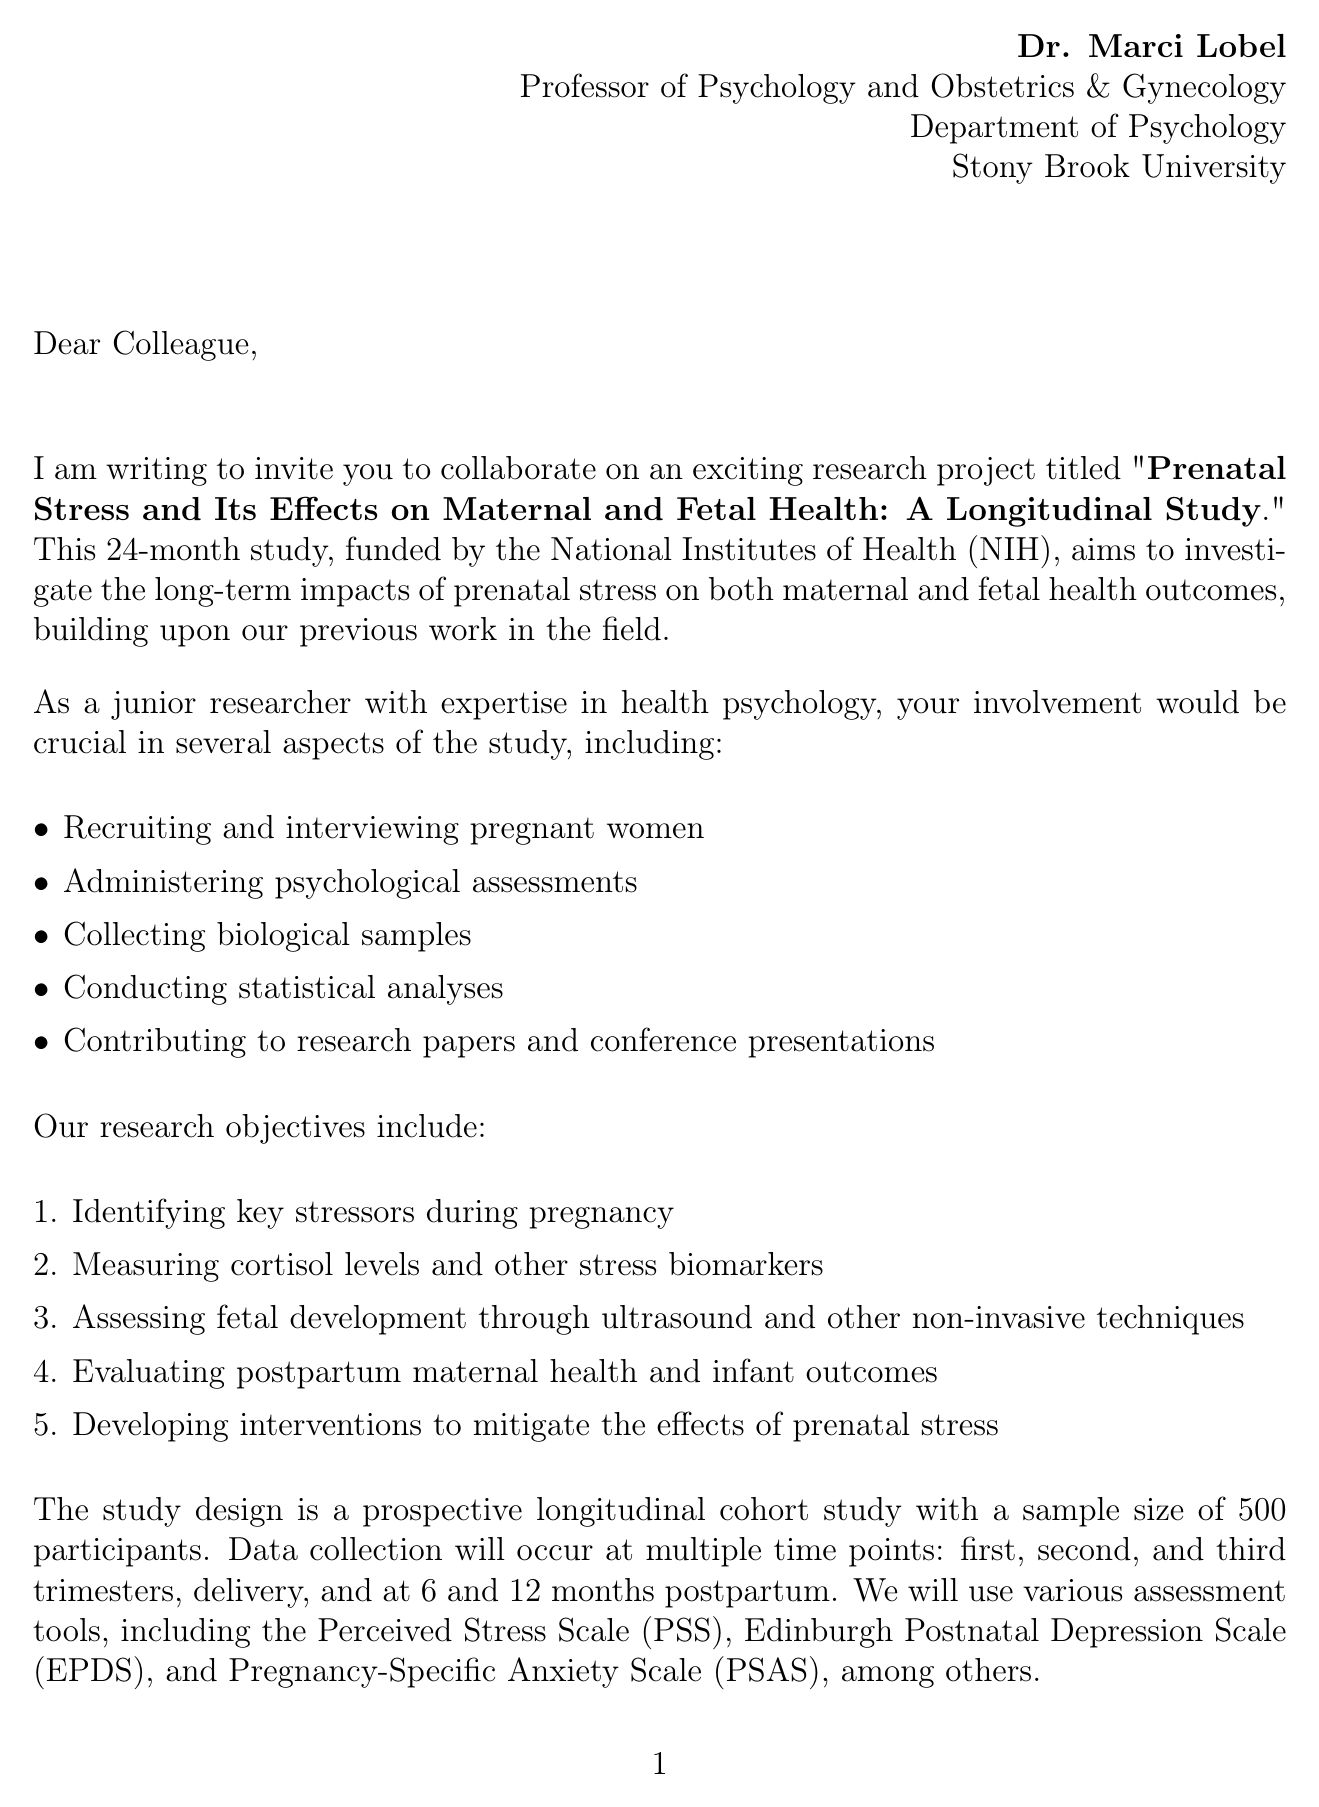What is the title of the research project? The title is stated in the beginning of the letter as "Prenatal Stress and Its Effects on Maternal and Fetal Health: A Longitudinal Study."
Answer: Prenatal Stress and Its Effects on Maternal and Fetal Health: A Longitudinal Study Who is the sender of the letter? The sender's details are provided at the top of the document, identifying the sender as Dr. Marci Lobel.
Answer: Dr. Marci Lobel How long is the duration of the study? The duration is explicitly mentioned in the document as 24 months.
Answer: 24 months What is one of the specific tasks the junior researcher will perform? The document lists specific tasks that the junior researcher will be involved in; one of them is "Recruiting and interviewing pregnant women."
Answer: Recruiting and interviewing pregnant women What is the sample size for the study? The sample size is stated as 500 participants in the methodology section of the letter.
Answer: 500 What agency is funding the study? The funding source is mentioned at the top of the letter as the National Institutes of Health (NIH).
Answer: National Institutes of Health (NIH) What is the response deadline for the collaboration invitation? The document specifies the response deadline clearly as "Within two weeks."
Answer: Within two weeks What is one key benefit of collaborating on this project? One of the benefits listed in the letter is "Opportunity to work with a leading expert in prenatal stress research."
Answer: Opportunity to work with a leading expert in prenatal stress research What type of study design is mentioned in the project? The study design is characterized in the document, indicating it is a "Prospective longitudinal cohort study."
Answer: Prospective longitudinal cohort study 